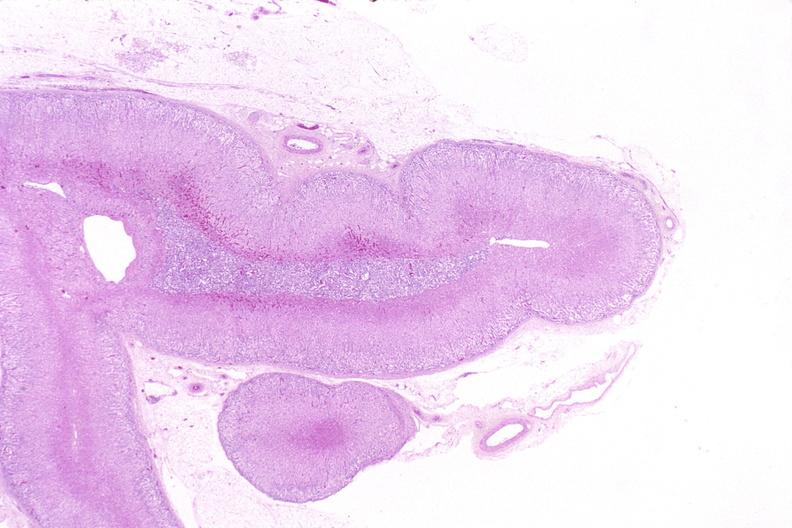what does this image show?
Answer the question using a single word or phrase. Adrenal gland 